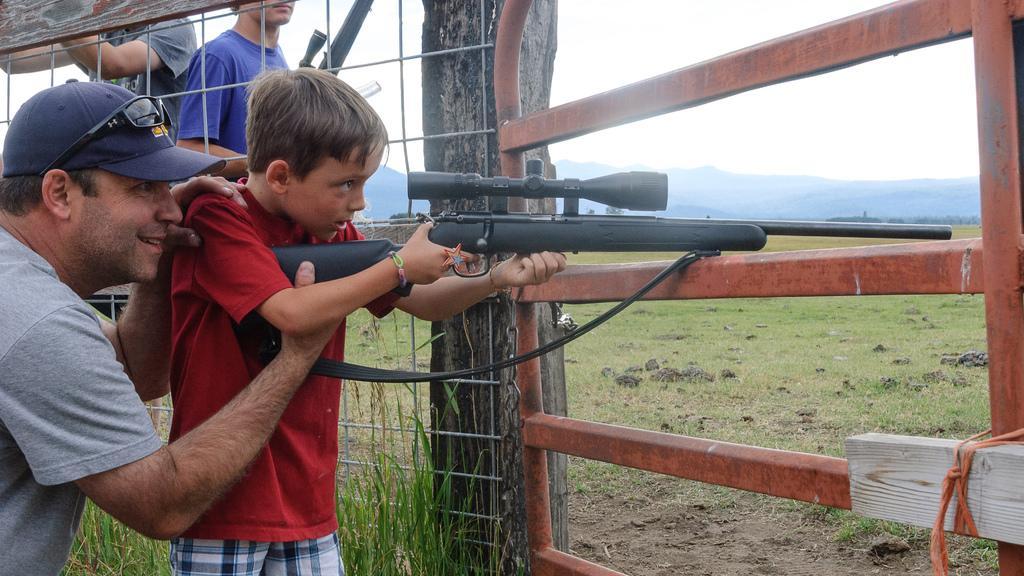Please provide a concise description of this image. As we can see in the image there is fence, grass and at the top there is sky. There are few people. The boy standing over here is wearing red color t shirt and holding gun. In the background there are hills. 